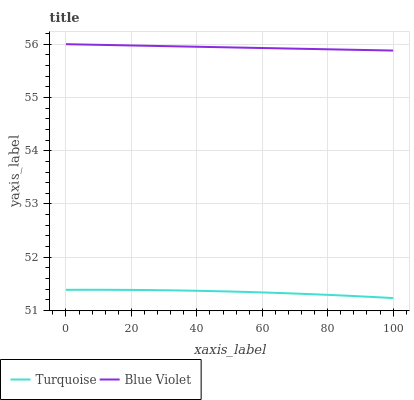Does Turquoise have the minimum area under the curve?
Answer yes or no. Yes. Does Blue Violet have the maximum area under the curve?
Answer yes or no. Yes. Does Blue Violet have the minimum area under the curve?
Answer yes or no. No. Is Blue Violet the smoothest?
Answer yes or no. Yes. Is Turquoise the roughest?
Answer yes or no. Yes. Is Blue Violet the roughest?
Answer yes or no. No. Does Turquoise have the lowest value?
Answer yes or no. Yes. Does Blue Violet have the lowest value?
Answer yes or no. No. Does Blue Violet have the highest value?
Answer yes or no. Yes. Is Turquoise less than Blue Violet?
Answer yes or no. Yes. Is Blue Violet greater than Turquoise?
Answer yes or no. Yes. Does Turquoise intersect Blue Violet?
Answer yes or no. No. 